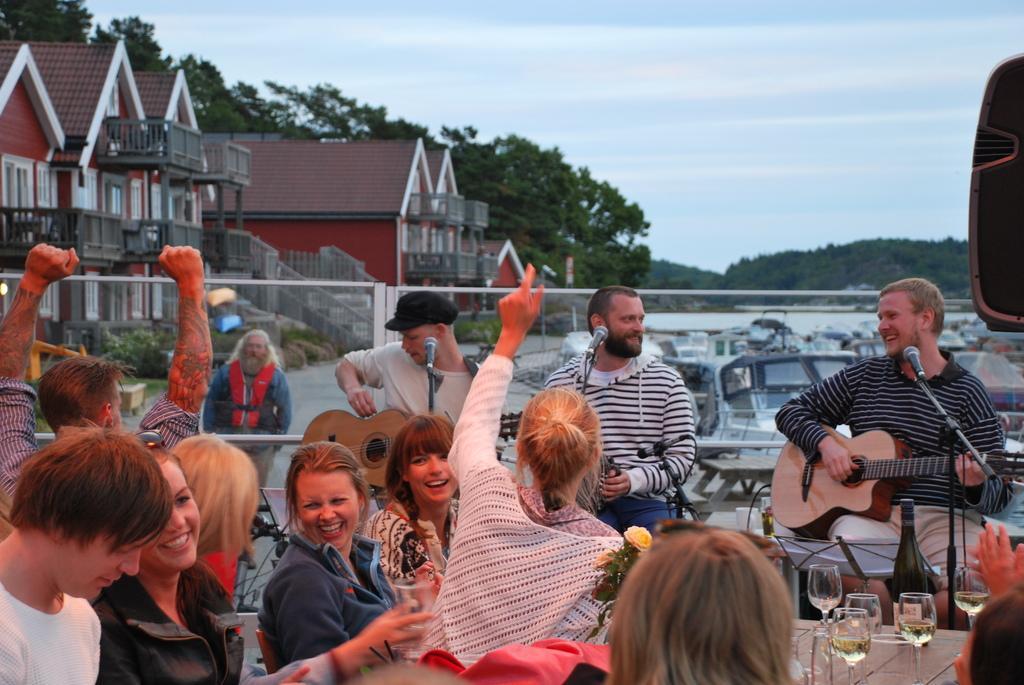Describe this image in one or two sentences. Three people are playing music at a restaurant. Some people are enjoying the music sitting at tables in front of them. 